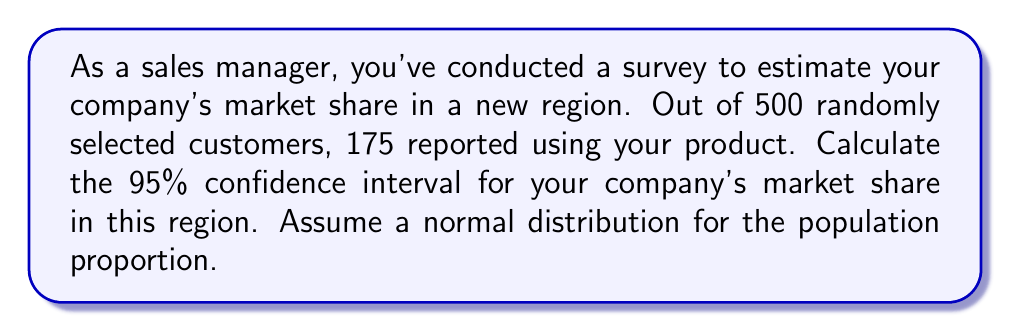Can you solve this math problem? Let's approach this step-by-step:

1) First, we need to calculate the sample proportion:
   $\hat{p} = \frac{\text{number of successes}}{\text{sample size}} = \frac{175}{500} = 0.35$

2) The formula for the confidence interval of a proportion is:
   $$\hat{p} \pm z_{\alpha/2} \sqrt{\frac{\hat{p}(1-\hat{p})}{n}}$$
   where $z_{\alpha/2}$ is the critical value for the desired confidence level.

3) For a 95% confidence interval, $z_{\alpha/2} = 1.96$

4) Now, let's substitute our values:
   $n = 500$
   $\hat{p} = 0.35$

5) Calculate the standard error:
   $$SE = \sqrt{\frac{\hat{p}(1-\hat{p})}{n}} = \sqrt{\frac{0.35(1-0.35)}{500}} = 0.0213$$

6) Now we can compute the margin of error:
   $$ME = z_{\alpha/2} \cdot SE = 1.96 \cdot 0.0213 = 0.0418$$

7) Finally, we can calculate the confidence interval:
   $$0.35 \pm 0.0418$$
   
   Lower bound: $0.35 - 0.0418 = 0.3082$
   Upper bound: $0.35 + 0.0418 = 0.3918$

Therefore, we can say with 95% confidence that the true market share is between 30.82% and 39.18%.
Answer: (0.3082, 0.3918) or 30.82% to 39.18% 